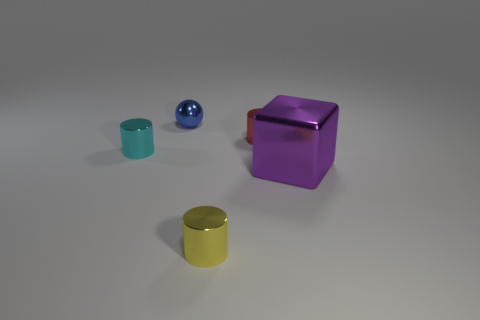Add 3 red objects. How many objects exist? 8 Subtract all spheres. How many objects are left? 4 Subtract 0 brown balls. How many objects are left? 5 Subtract all small cyan cylinders. Subtract all big purple blocks. How many objects are left? 3 Add 5 large metallic blocks. How many large metallic blocks are left? 6 Add 1 tiny blue balls. How many tiny blue balls exist? 2 